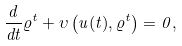<formula> <loc_0><loc_0><loc_500><loc_500>\frac { d } { d t } \varrho ^ { t } + \upsilon \left ( u ( t ) , \varrho ^ { t } \right ) = 0 ,</formula> 